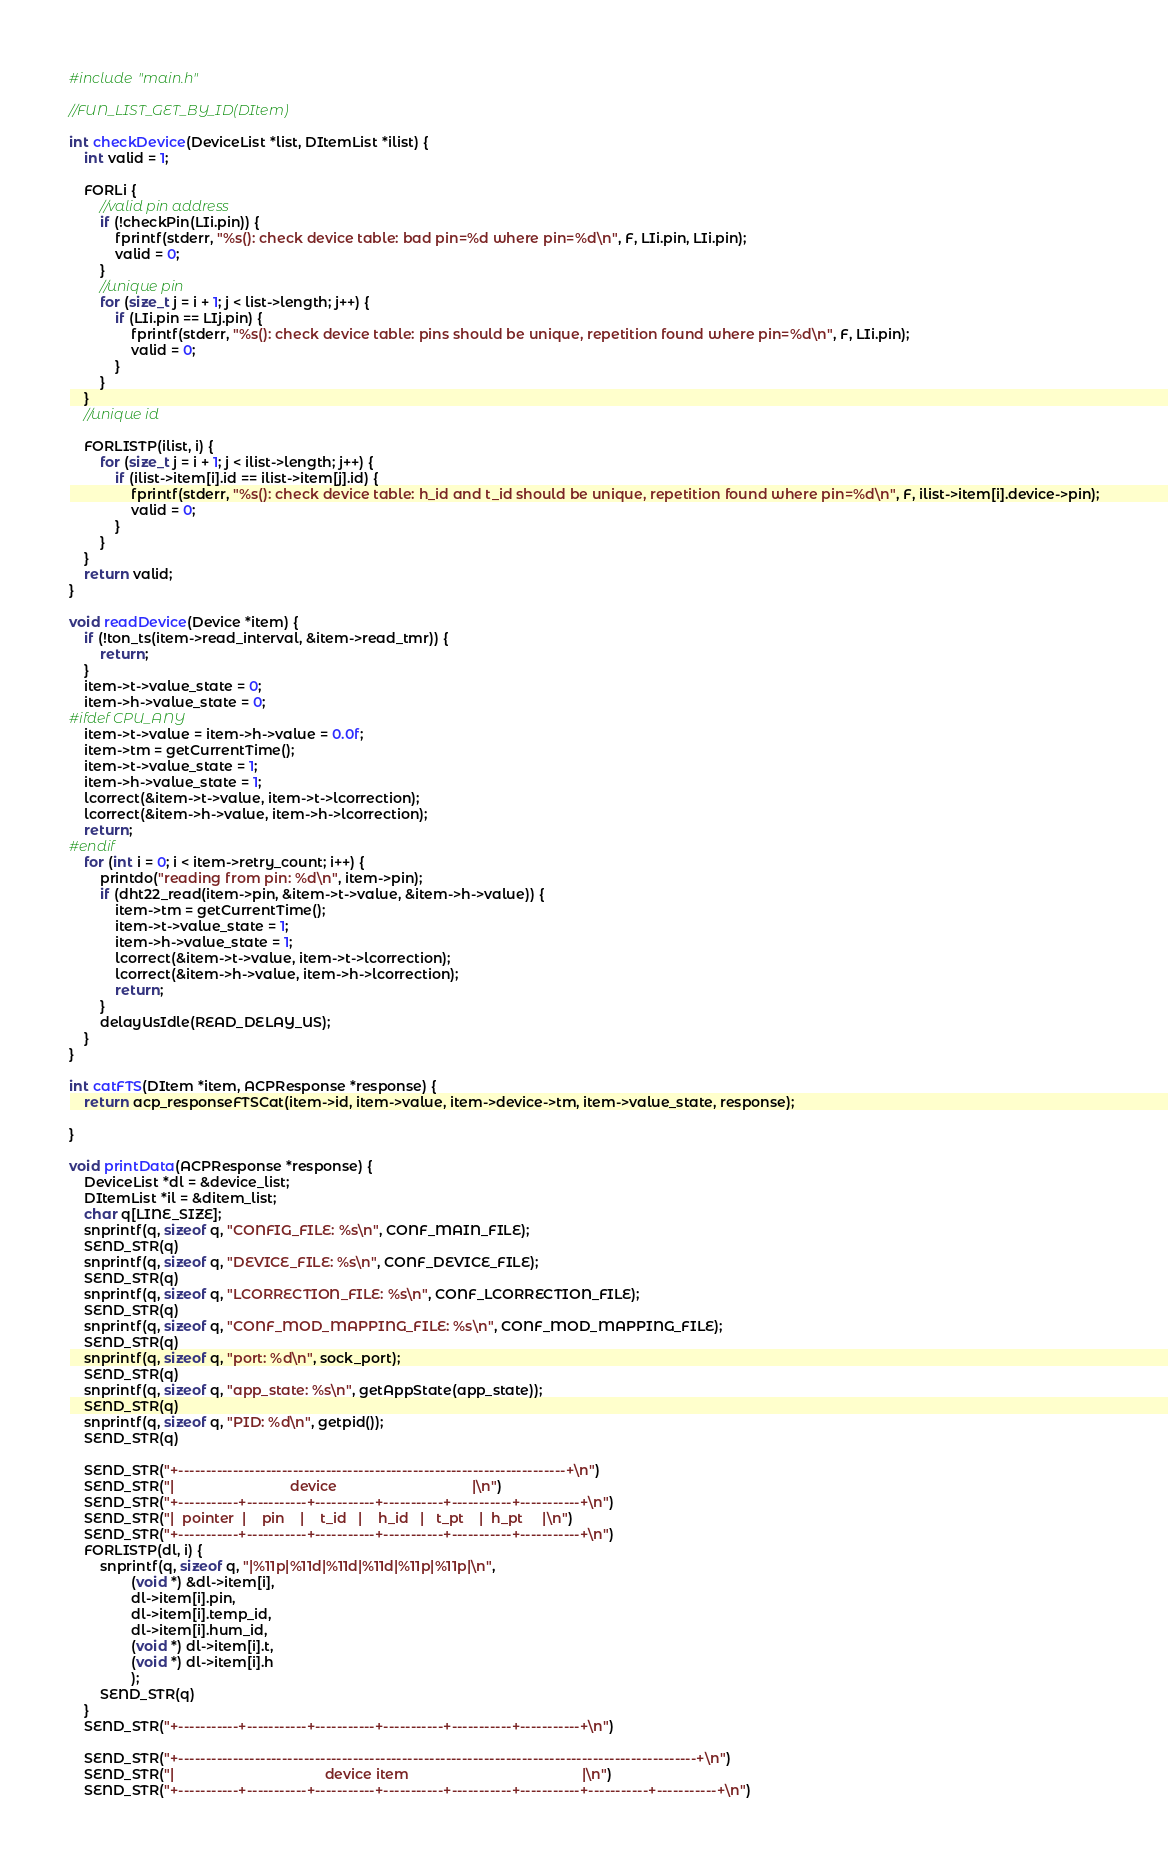Convert code to text. <code><loc_0><loc_0><loc_500><loc_500><_C_>
#include "main.h"

//FUN_LIST_GET_BY_ID(DItem)

int checkDevice(DeviceList *list, DItemList *ilist) {
    int valid = 1;

    FORLi {
        //valid pin address
        if (!checkPin(LIi.pin)) {
            fprintf(stderr, "%s(): check device table: bad pin=%d where pin=%d\n", F, LIi.pin, LIi.pin);
            valid = 0;
        }
        //unique pin
        for (size_t j = i + 1; j < list->length; j++) {
            if (LIi.pin == LIj.pin) {
                fprintf(stderr, "%s(): check device table: pins should be unique, repetition found where pin=%d\n", F, LIi.pin);
                valid = 0;
            }
        }
    }
    //unique id

    FORLISTP(ilist, i) {
        for (size_t j = i + 1; j < ilist->length; j++) {
            if (ilist->item[i].id == ilist->item[j].id) {
                fprintf(stderr, "%s(): check device table: h_id and t_id should be unique, repetition found where pin=%d\n", F, ilist->item[i].device->pin);
                valid = 0;
            }
        }
    }
    return valid;
}

void readDevice(Device *item) {
    if (!ton_ts(item->read_interval, &item->read_tmr)) {
        return;
    }
    item->t->value_state = 0;
    item->h->value_state = 0;
#ifdef CPU_ANY
    item->t->value = item->h->value = 0.0f;
    item->tm = getCurrentTime();
    item->t->value_state = 1;
    item->h->value_state = 1;
    lcorrect(&item->t->value, item->t->lcorrection);
    lcorrect(&item->h->value, item->h->lcorrection);
    return;
#endif
    for (int i = 0; i < item->retry_count; i++) {
        printdo("reading from pin: %d\n", item->pin);
        if (dht22_read(item->pin, &item->t->value, &item->h->value)) {
            item->tm = getCurrentTime();
            item->t->value_state = 1;
            item->h->value_state = 1;
            lcorrect(&item->t->value, item->t->lcorrection);
            lcorrect(&item->h->value, item->h->lcorrection);
            return;
        }
        delayUsIdle(READ_DELAY_US);
    }
}

int catFTS(DItem *item, ACPResponse *response) {
    return acp_responseFTSCat(item->id, item->value, item->device->tm, item->value_state, response);

}

void printData(ACPResponse *response) {
    DeviceList *dl = &device_list;
    DItemList *il = &ditem_list;
    char q[LINE_SIZE];
    snprintf(q, sizeof q, "CONFIG_FILE: %s\n", CONF_MAIN_FILE);
    SEND_STR(q)
    snprintf(q, sizeof q, "DEVICE_FILE: %s\n", CONF_DEVICE_FILE);
    SEND_STR(q)
    snprintf(q, sizeof q, "LCORRECTION_FILE: %s\n", CONF_LCORRECTION_FILE);
    SEND_STR(q)
    snprintf(q, sizeof q, "CONF_MOD_MAPPING_FILE: %s\n", CONF_MOD_MAPPING_FILE);
    SEND_STR(q)
    snprintf(q, sizeof q, "port: %d\n", sock_port);
    SEND_STR(q)
    snprintf(q, sizeof q, "app_state: %s\n", getAppState(app_state));
    SEND_STR(q)
    snprintf(q, sizeof q, "PID: %d\n", getpid());
    SEND_STR(q)

    SEND_STR("+-----------------------------------------------------------------------+\n")
    SEND_STR("|                              device                                   |\n")
    SEND_STR("+-----------+-----------+-----------+-----------+-----------+-----------+\n")
    SEND_STR("|  pointer  |    pin    |    t_id   |    h_id   |   t_pt    |  h_pt     |\n")
    SEND_STR("+-----------+-----------+-----------+-----------+-----------+-----------+\n")
    FORLISTP(dl, i) {
        snprintf(q, sizeof q, "|%11p|%11d|%11d|%11d|%11p|%11p|\n",
                (void *) &dl->item[i],
                dl->item[i].pin,
                dl->item[i].temp_id,
                dl->item[i].hum_id,
                (void *) dl->item[i].t,
                (void *) dl->item[i].h
                );
        SEND_STR(q)
    }
    SEND_STR("+-----------+-----------+-----------+-----------+-----------+-----------+\n")

    SEND_STR("+-----------------------------------------------------------------------------------------------+\n")
    SEND_STR("|                                       device item                                             |\n")
    SEND_STR("+-----------+-----------+-----------+-----------+-----------+-----------+-----------+-----------+\n")</code> 